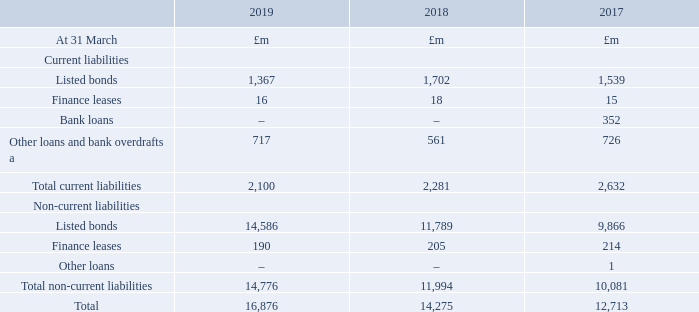25. Loans and other borrowings continued
Loans and other borrowings are analysed as follows:
a Includes collateral received on swaps of £638m (2017/18: £525m, 2016/17: £702m).
The carrying values disclosed in the above table reflect balances at amortised cost adjusted for accrued interest and fair value adjustments to the relevant loans or borrowings. These do not reflect the final principal repayments that will arise after taking account of the relevant derivatives in hedging relationships which are reflected in the table below. Apart from finance leases, all borrowings as at 31 March 2019, 2018 and 2017 were unsecured.
What was the collateral received on swaps in 2019? £638m. What does the carrying value reflect? Balances at amortised cost adjusted for accrued interest and fair value adjustments to the relevant loans or borrowings. What was the amount of listed bonds in 2019, 2018 and 2017 respectively?
Answer scale should be: million. 1,367, 1,702, 1,539. What is the change in listed bonds from 2018 to 2019?
Answer scale should be: million. 1,367 - 1,702
Answer: -335. What is the average Finance leases for 2017-2019?
Answer scale should be: million. (16 + 18 + 15) / 3
Answer: 16.33. In which year(s) are there are no bank loans?
Answer scale should be: million. Locate and analyze finance leases in row 5
answer: 2019, 2018. 